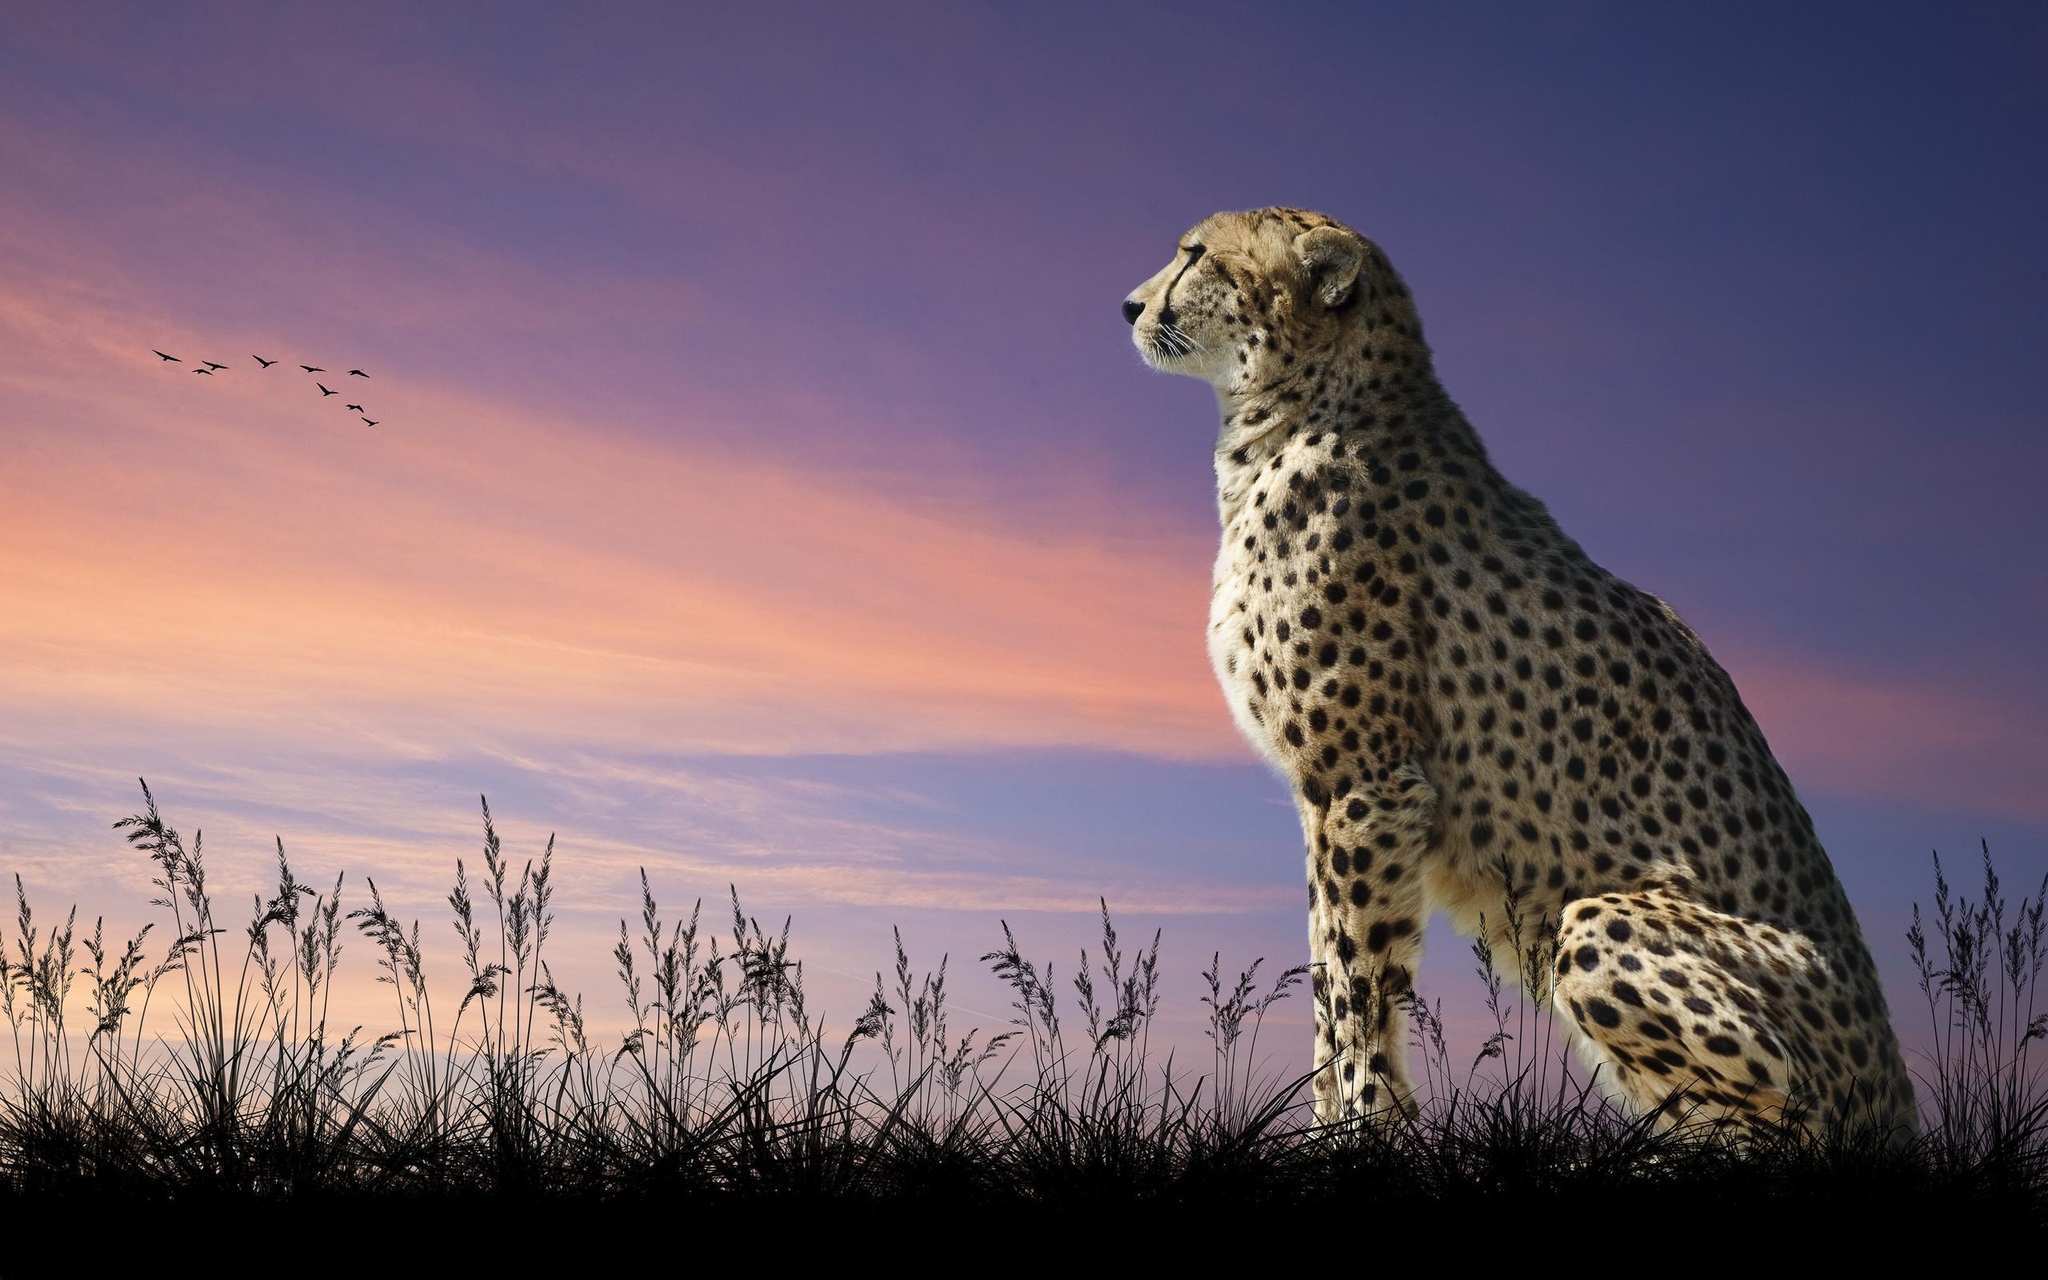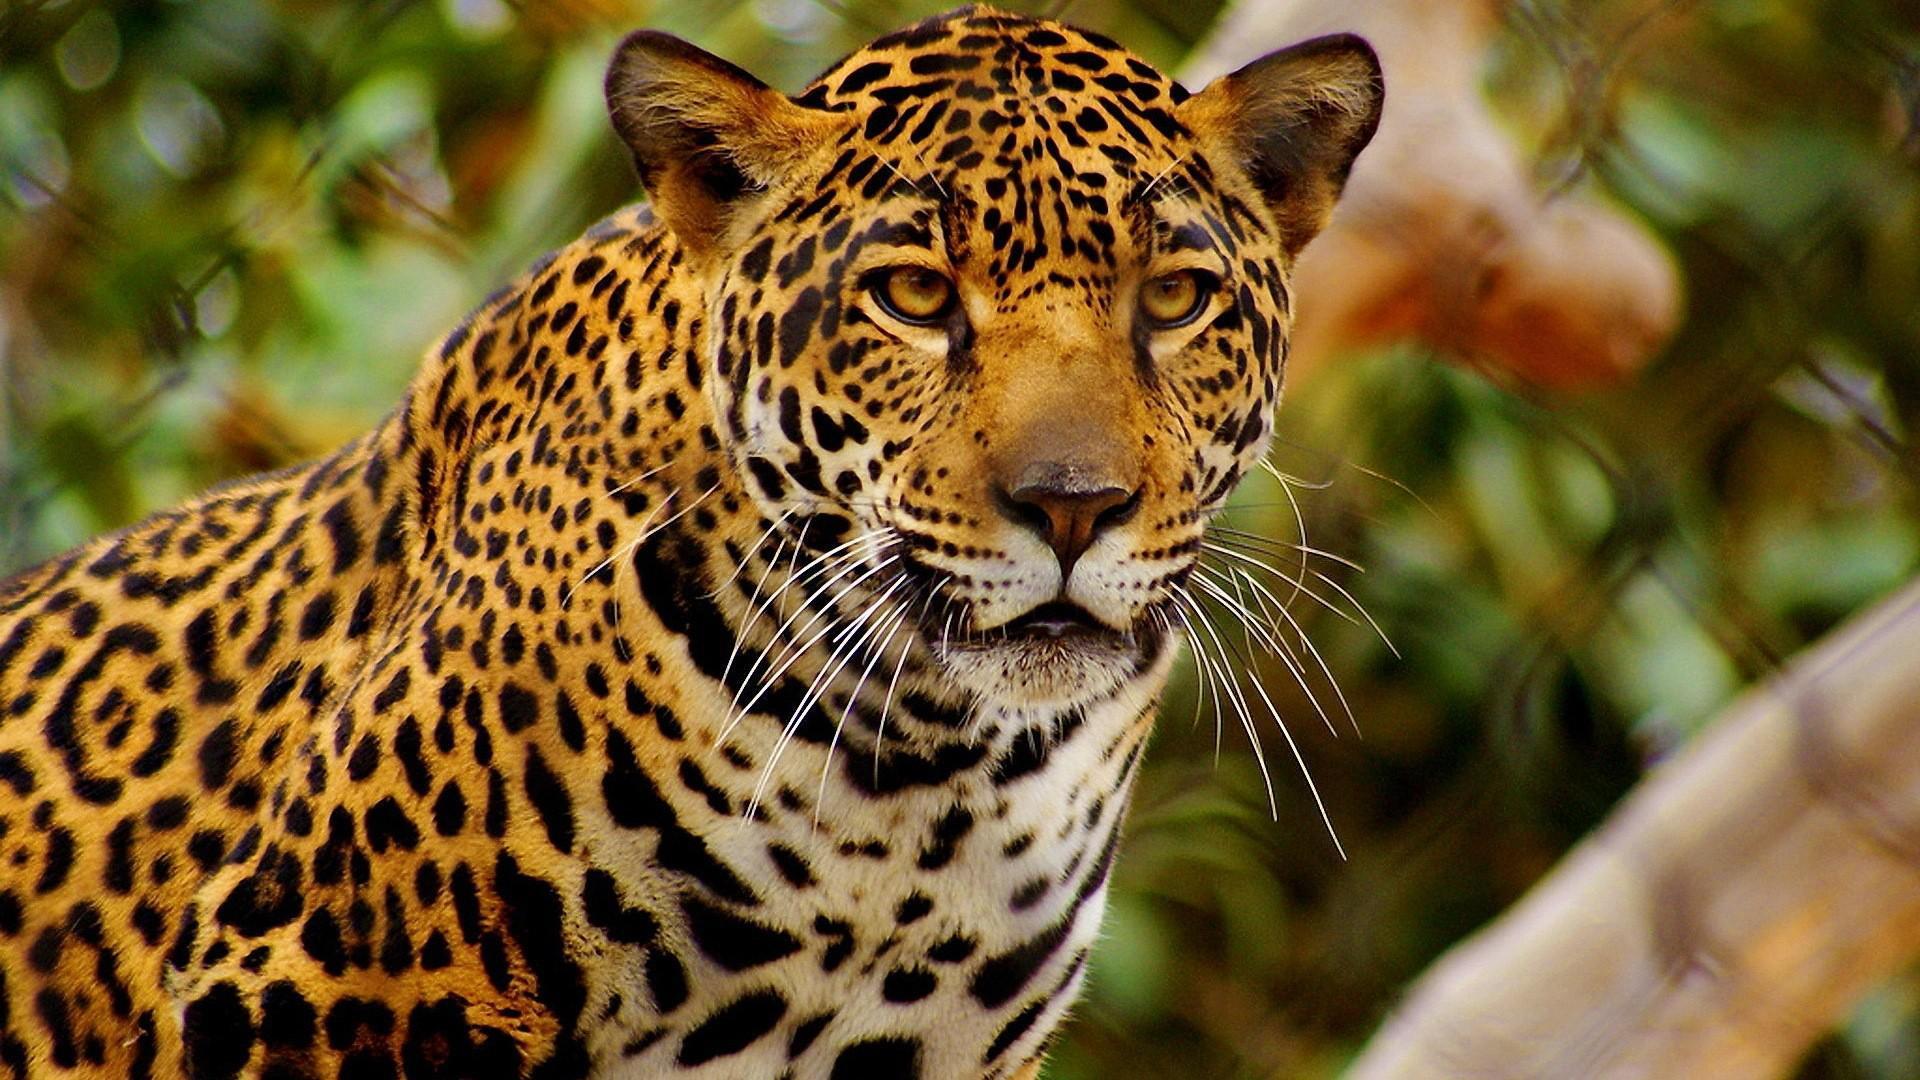The first image is the image on the left, the second image is the image on the right. For the images displayed, is the sentence "An image shows a cheetah bounding across the grass with front paws off the ground." factually correct? Answer yes or no. No. The first image is the image on the left, the second image is the image on the right. For the images displayed, is the sentence "The left image contains at least two cheetahs." factually correct? Answer yes or no. No. 